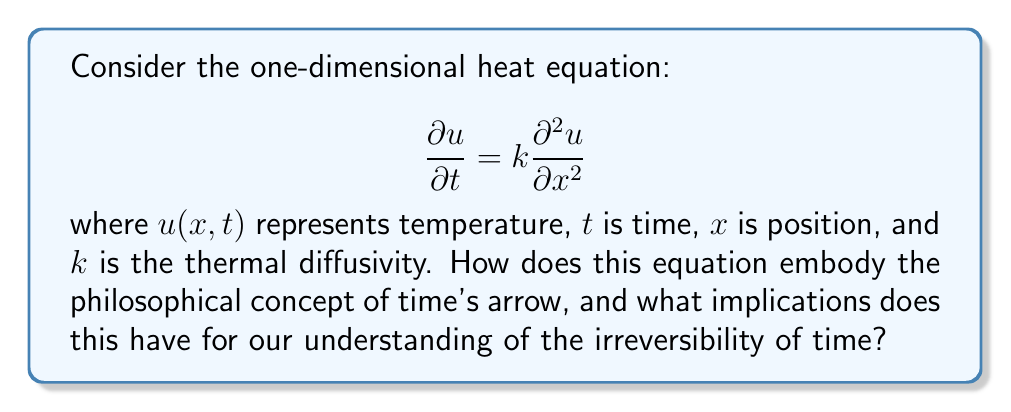Help me with this question. 1. The heat equation describes the diffusion of heat over time. Let's break down its philosophical implications:

2. Time's arrow in the heat equation:
   - The equation is first-order in time ($\frac{\partial u}{\partial t}$) but second-order in space ($\frac{\partial^2 u}{\partial x^2}$).
   - This asymmetry between time and space derivatives reflects the unidirectional nature of time.

3. Irreversibility:
   - Solutions to the heat equation tend to evolve towards uniform temperature distributions.
   - This process is irreversible without external intervention, mirroring the Second Law of Thermodynamics.

4. Consider two identical systems with different initial temperature distributions:
   - Over time, both systems will approach the same uniform temperature.
   - Information about the initial states is lost, demonstrating entropy increase.

5. Philosophical interpretation:
   - The heat equation embodies the idea that time flows in one direction.
   - It suggests that the future is determined by the past, but the past cannot be uniquely determined from the future.

6. Contrast with time-reversible equations:
   - Newton's laws of motion are time-reversible.
   - The heat equation, however, describes a process that has a preferred direction in time.

7. Implications for free will and determinism:
   - The irreversibility in the heat equation might be seen as a challenge to the idea of free will.
   - It suggests that certain macroscopic processes have an inherent "arrow of time."

8. Connection to human experience:
   - Our perception of time as unidirectional aligns with the behavior described by the heat equation.
   - This mathematical model provides a framework for understanding our experiential sense of time's passage.
Answer: The heat equation embodies time's arrow through its asymmetric treatment of time and space derivatives, describing irreversible processes that align with our perception of time's unidirectional flow. 